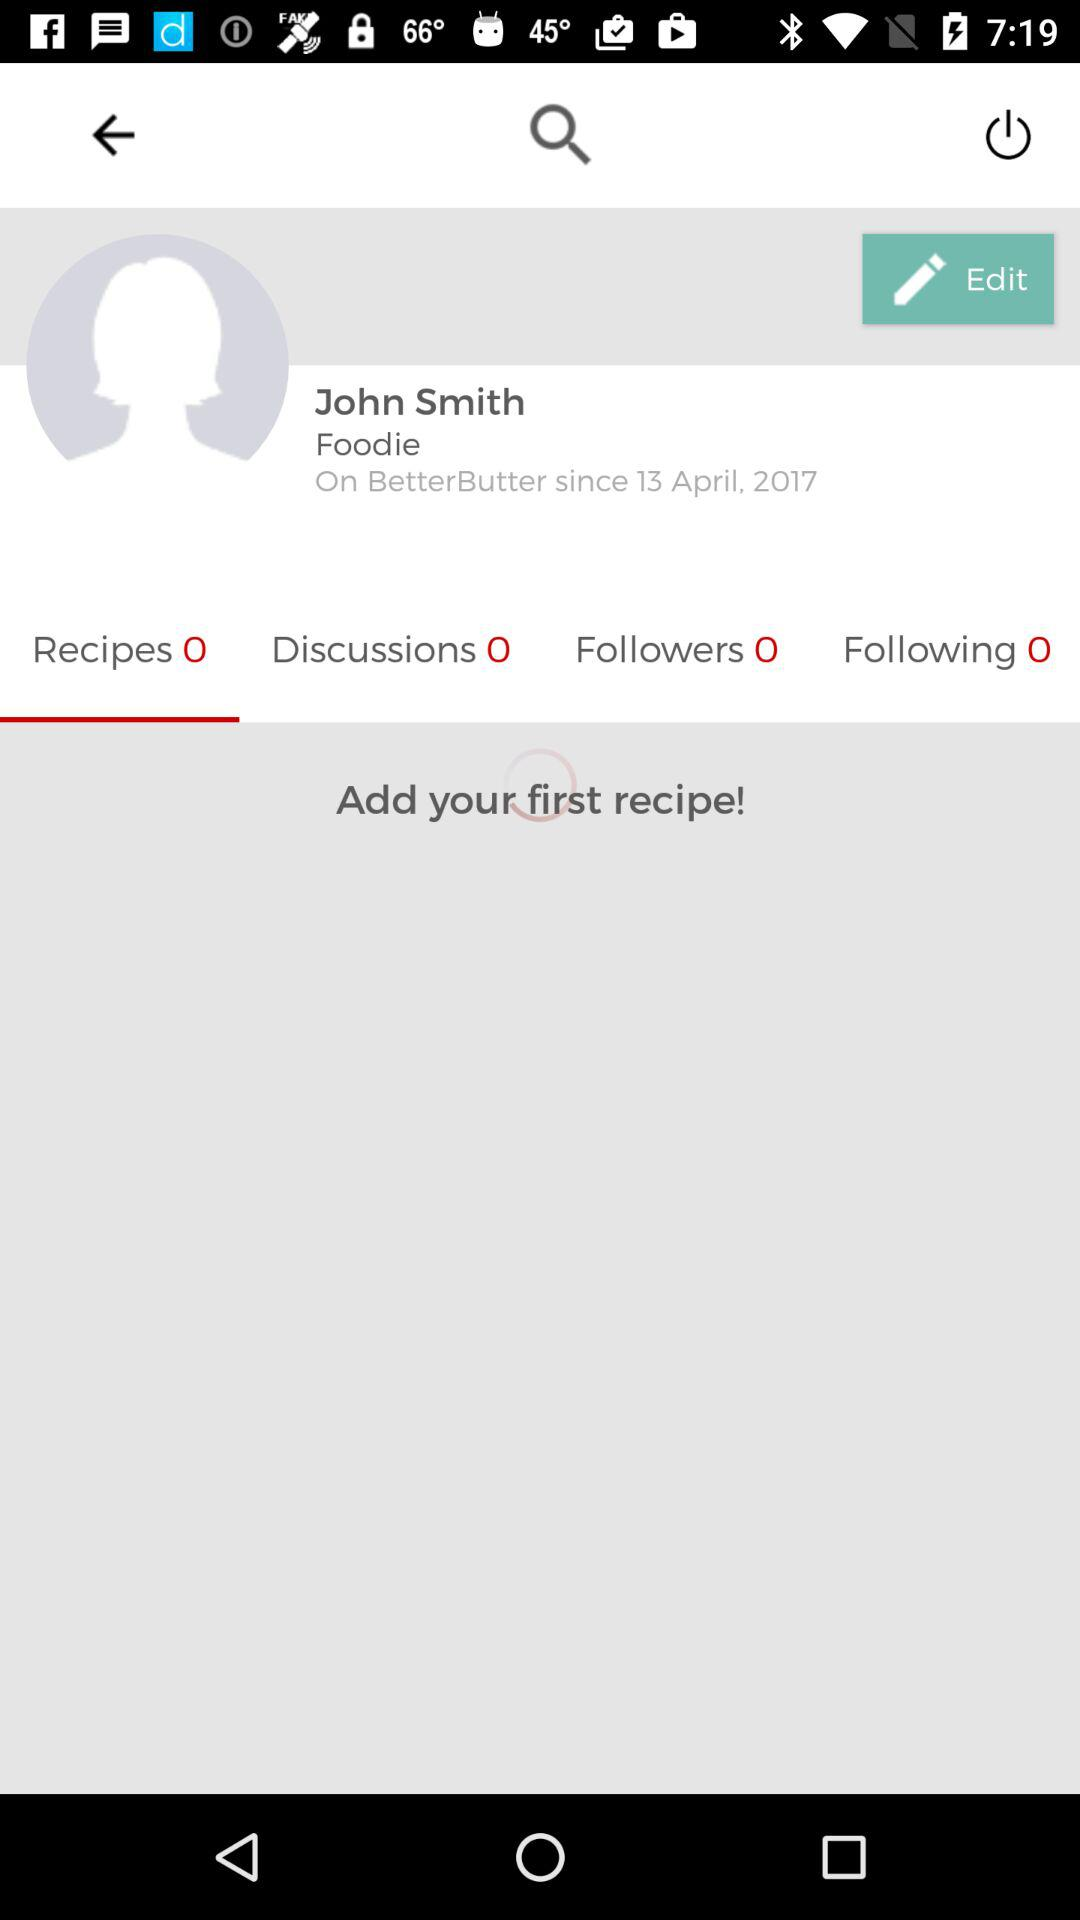Which tab is selected? The selected tab is "Recipes". 